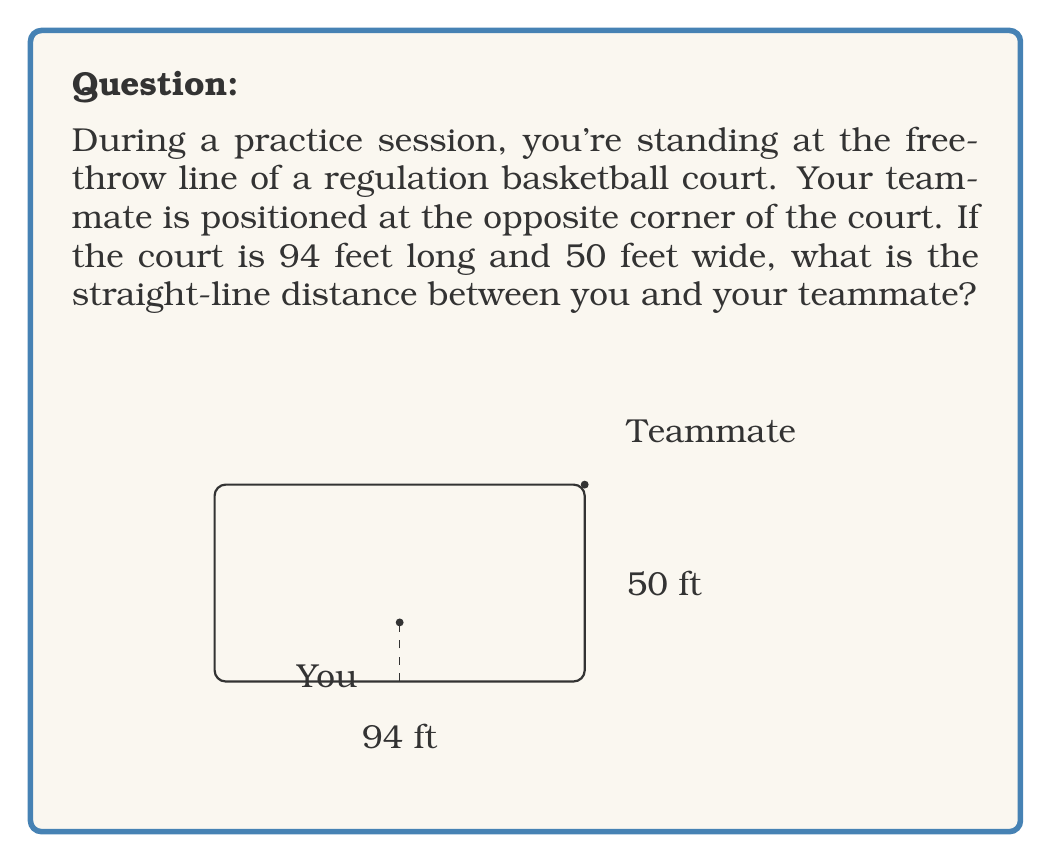What is the answer to this math problem? Let's approach this step-by-step using the Pythagorean theorem:

1) First, we need to identify the right triangle formed by your position, your teammate's position, and the corner of the court.

2) The base of this triangle is the full length of the court minus the distance from the baseline to the free-throw line. 
   - A regulation court is 94 feet long
   - The free-throw line is 15 feet from the baseline
   - So the base of our triangle is: $94 - 15 = 79$ feet

3) The height of the triangle is the full width of the court: 50 feet

4) Now we can apply the Pythagorean theorem: $a^2 + b^2 = c^2$
   Where $c$ is the distance we're looking for, $a$ is the base, and $b$ is the height.

5) Let's plug in our values:
   $$ 79^2 + 50^2 = c^2 $$

6) Simplify:
   $$ 6241 + 2500 = c^2 $$
   $$ 8741 = c^2 $$

7) Take the square root of both sides:
   $$ \sqrt{8741} = c $$

8) Simplify:
   $$ c \approx 93.49 $$

Therefore, the distance between you and your teammate is approximately 93.49 feet.
Answer: $93.49$ feet 